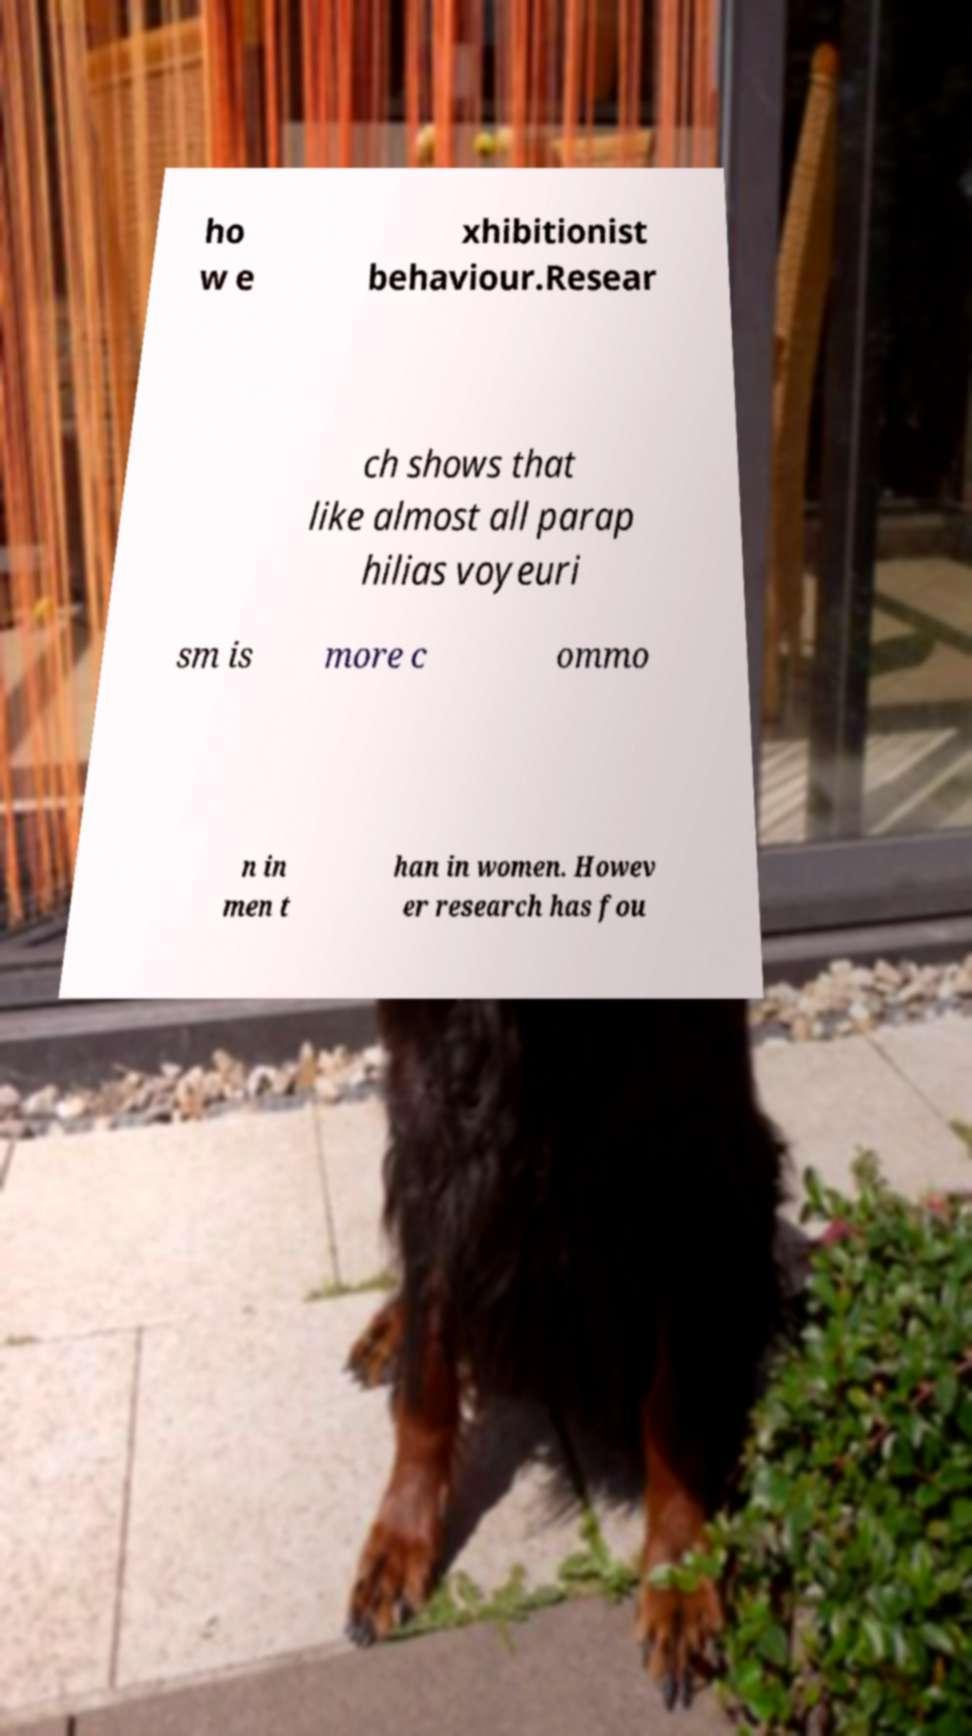Please identify and transcribe the text found in this image. ho w e xhibitionist behaviour.Resear ch shows that like almost all parap hilias voyeuri sm is more c ommo n in men t han in women. Howev er research has fou 